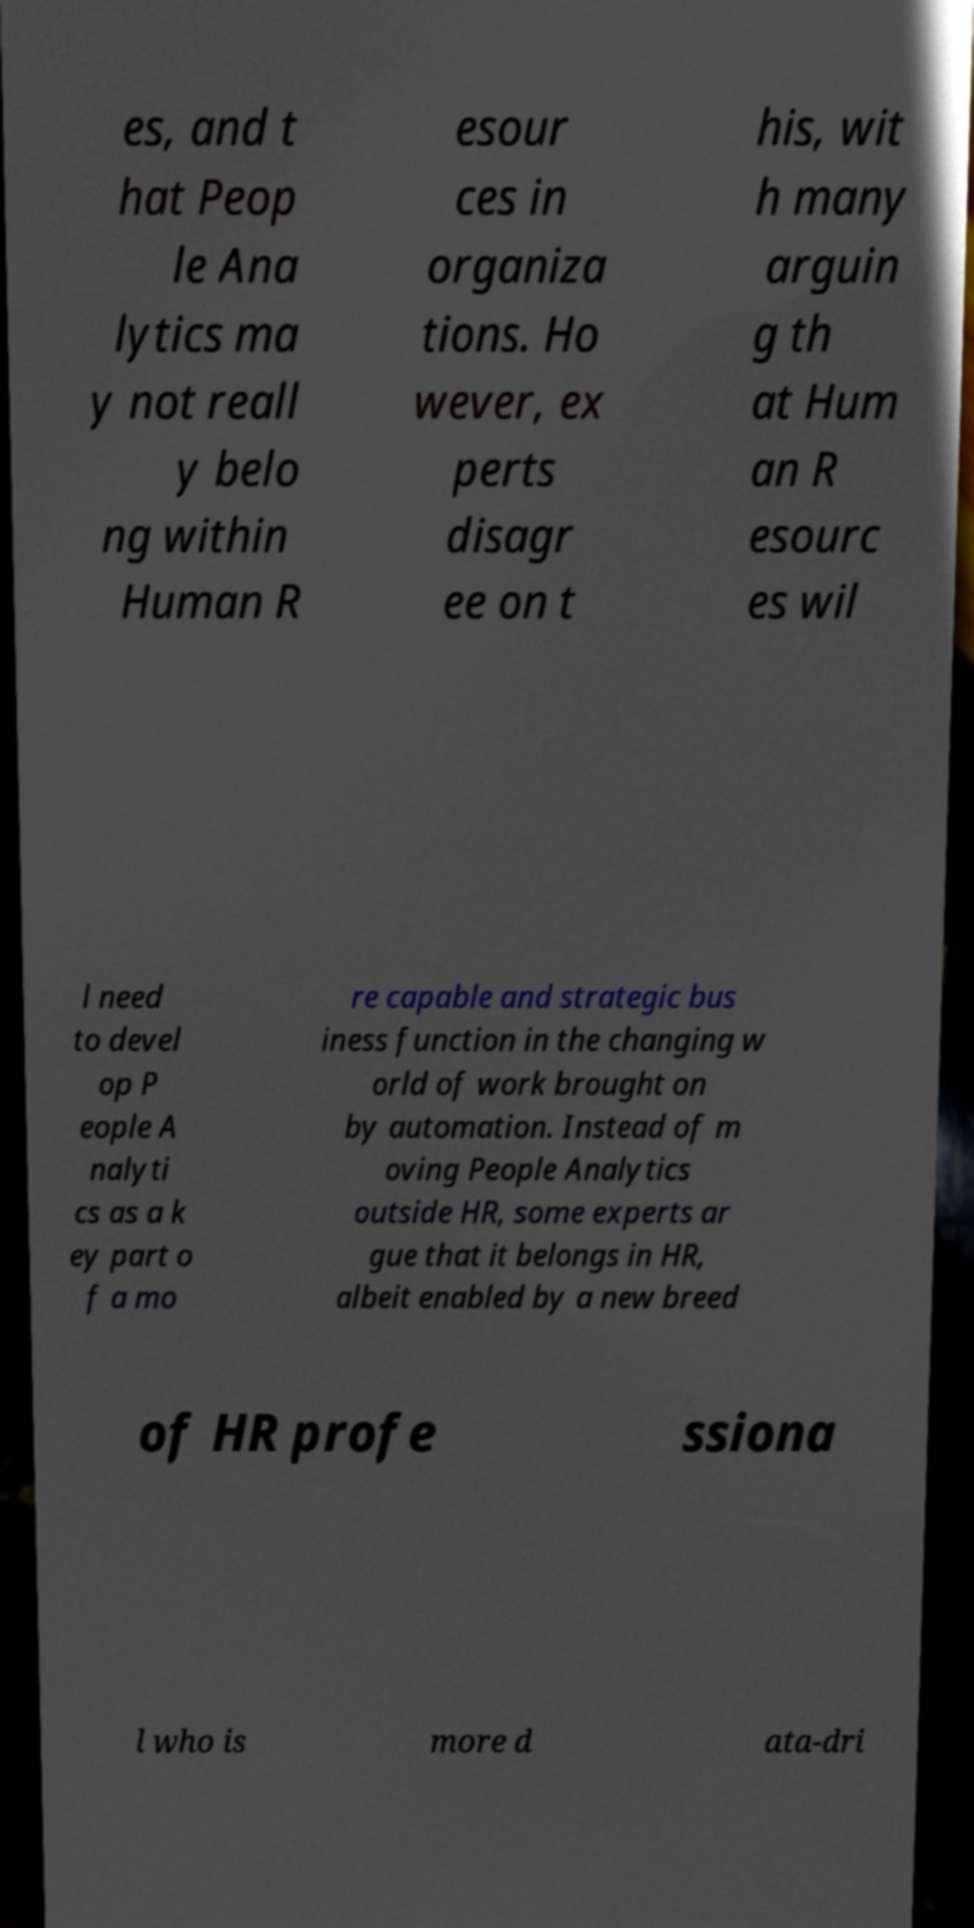Could you assist in decoding the text presented in this image and type it out clearly? es, and t hat Peop le Ana lytics ma y not reall y belo ng within Human R esour ces in organiza tions. Ho wever, ex perts disagr ee on t his, wit h many arguin g th at Hum an R esourc es wil l need to devel op P eople A nalyti cs as a k ey part o f a mo re capable and strategic bus iness function in the changing w orld of work brought on by automation. Instead of m oving People Analytics outside HR, some experts ar gue that it belongs in HR, albeit enabled by a new breed of HR profe ssiona l who is more d ata-dri 